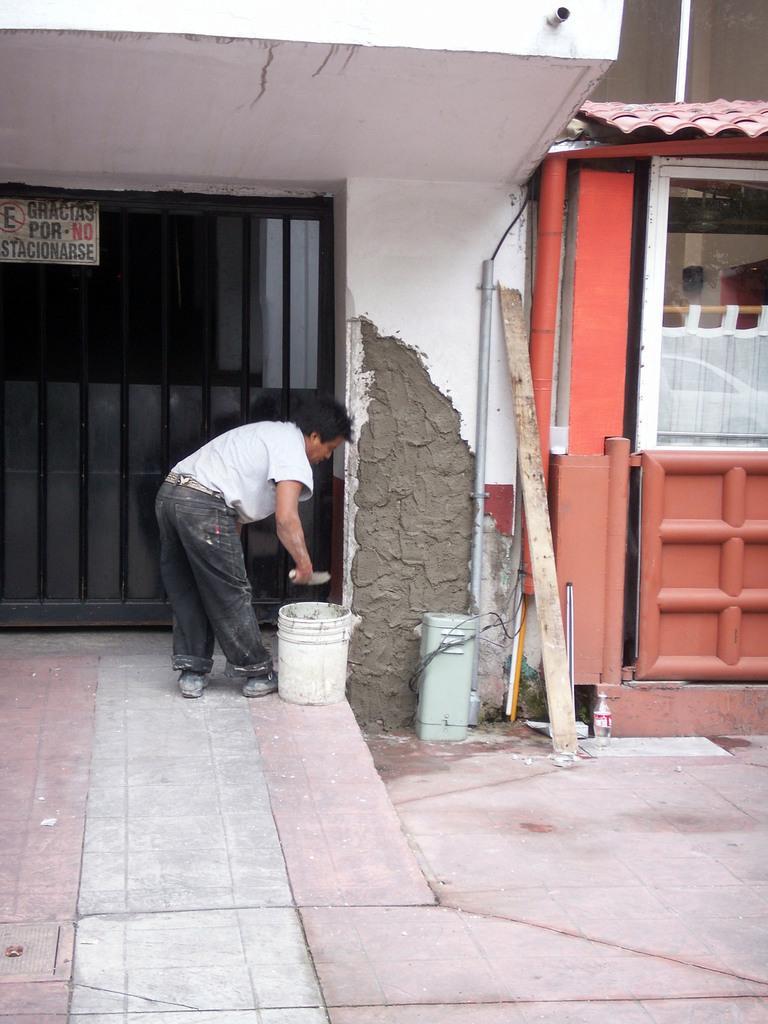Can you describe this image briefly? In this picture we can see a person is standing, there is a bucket beside him, on the left side we can see glasses and a board, we can see some text on this board, on the right side there is a box and a bottle. 